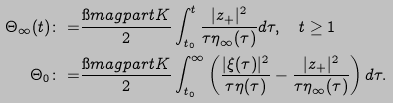Convert formula to latex. <formula><loc_0><loc_0><loc_500><loc_500>\Theta _ { \infty } ( t ) \colon = & \frac { \i m a g p a r t K } { 2 } \int _ { t _ { 0 } } ^ { t } \frac { | z _ { + } | ^ { 2 } } { \tau \eta _ { \infty } ( \tau ) } d \tau , \quad t \geq 1 \\ \Theta _ { 0 } \colon = & \frac { \i m a g p a r t K } { 2 } \int _ { t _ { 0 } } ^ { \infty } \left ( \frac { | \xi ( \tau ) | ^ { 2 } } { \tau \eta ( \tau ) } - \frac { | z _ { + } | ^ { 2 } } { \tau \eta _ { \infty } ( \tau ) } \right ) d \tau .</formula> 